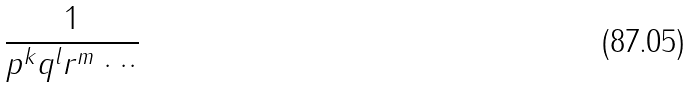<formula> <loc_0><loc_0><loc_500><loc_500>\frac { 1 } { p ^ { k } q ^ { l } r ^ { m } \cdot \cdot \cdot }</formula> 